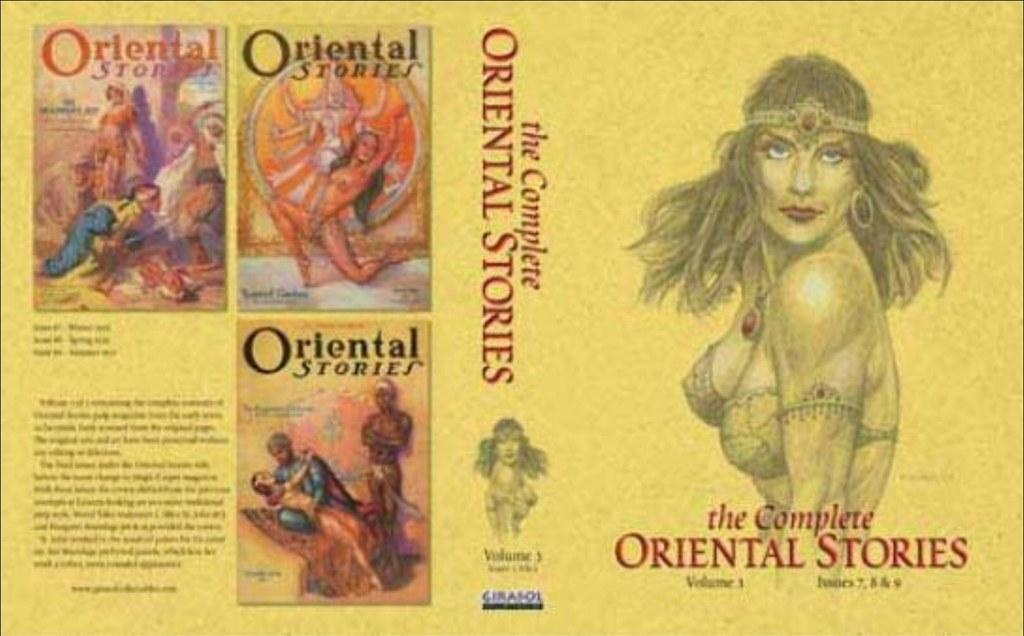What type of visual is the image? The image is a poster. Where is the woman located on the poster? There is a woman on the right side of the poster and another woman in the center of the poster. What can be found on the right side of the poster besides the woman? There is text on the right side of the poster. What is present in the center of the poster besides the woman? There is text in the center of the poster. What is depicted on the left side of the poster? There are cover photos of books on the left side of the poster. How many tomatoes are hanging from the bridge in the image? There are no tomatoes or bridges present in the image; it features a poster with a woman, text, and book cover photos. 